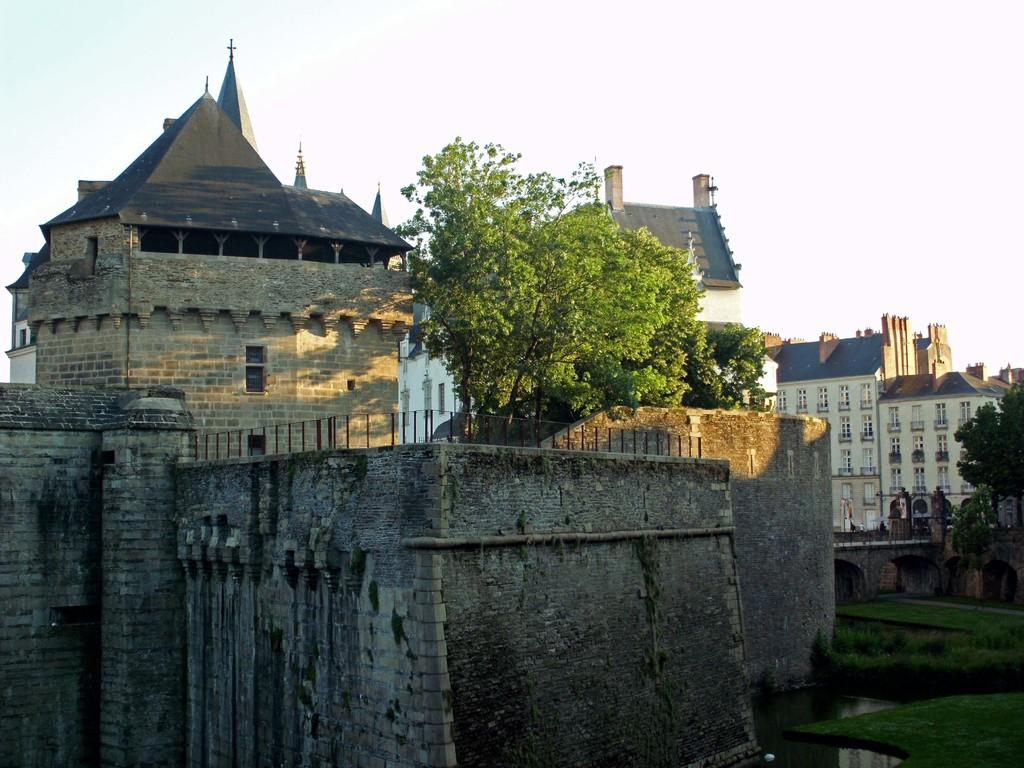What type of structures are present in the image? There is a group of buildings in the image. What features can be observed on the buildings? The buildings have windows and roofs. What type of vegetation is visible in the image? There is grass, plants, and a group of trees visible in the image. What natural elements can be seen in the image? There is water and the sky visible in the image. What is the condition of the sky in the image? The sky appears to be cloudy in the image. Where is the girl standing next to the oven in the image? There is no girl or oven present in the image. What type of glove is being used to tend to the plants in the image? There is no glove visible in the image, and no one is tending to the plants. 